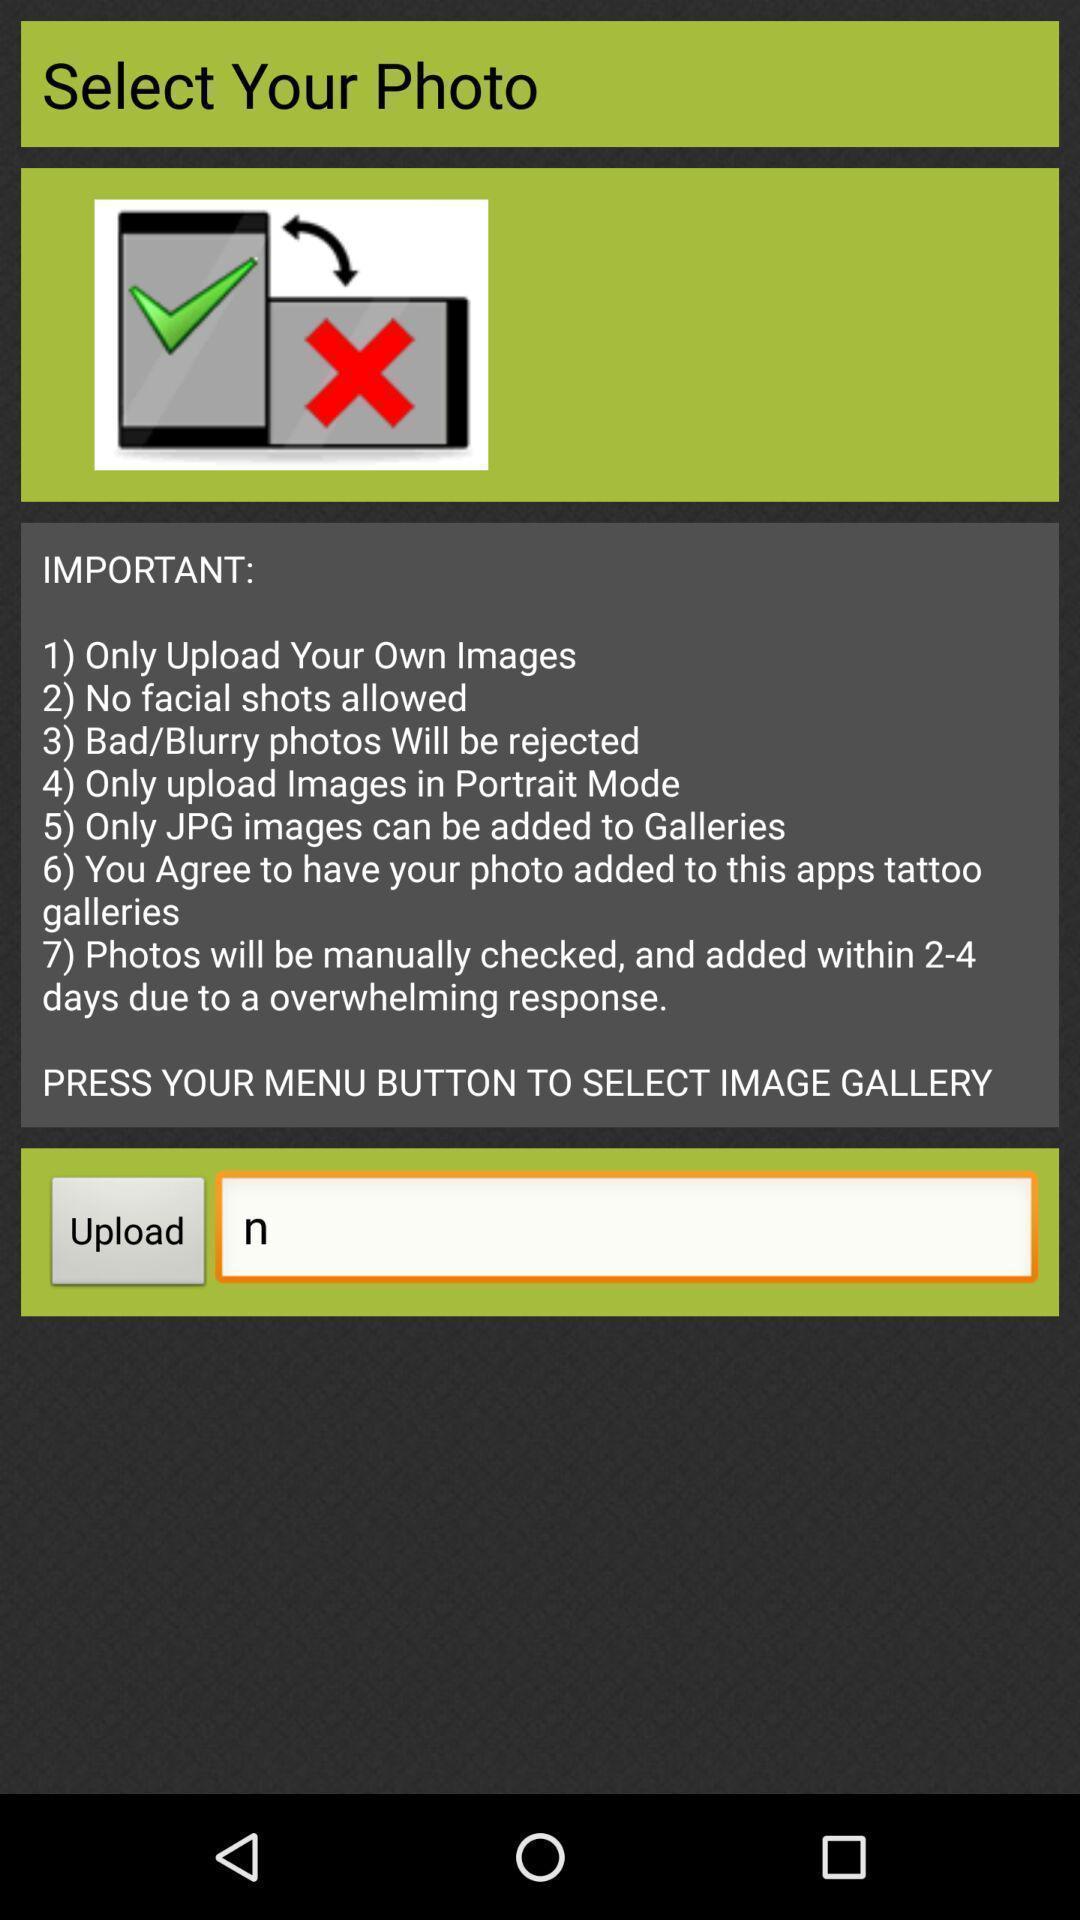What details can you identify in this image? Screen displaying instructions to upload a picture. 